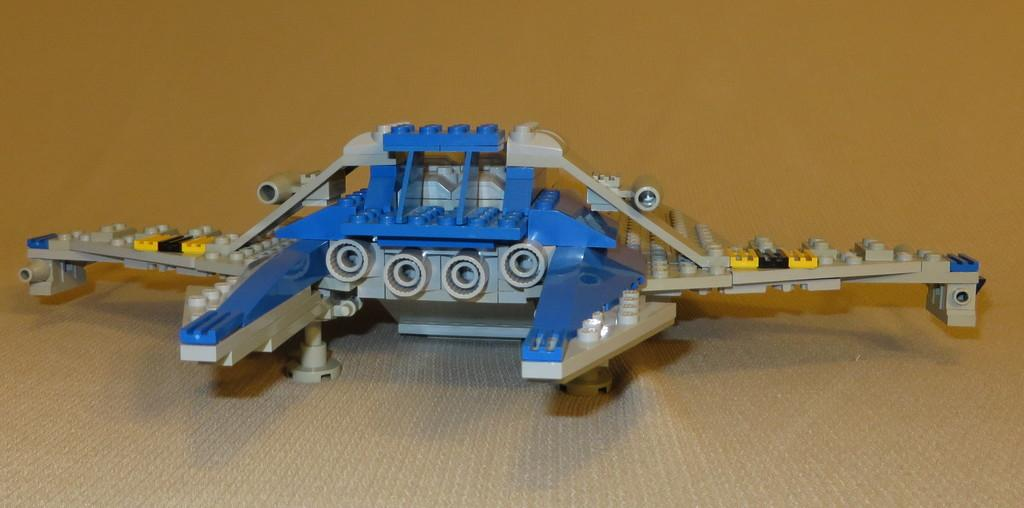What is the main subject in the center of the image? There is a lego toy in the center of the image. What type of flooring is visible at the bottom of the image? There is a carpet at the bottom of the image. How many drains are visible in the image? There are no drains present in the image. What type of cave is depicted in the image? There is no cave present in the image. 